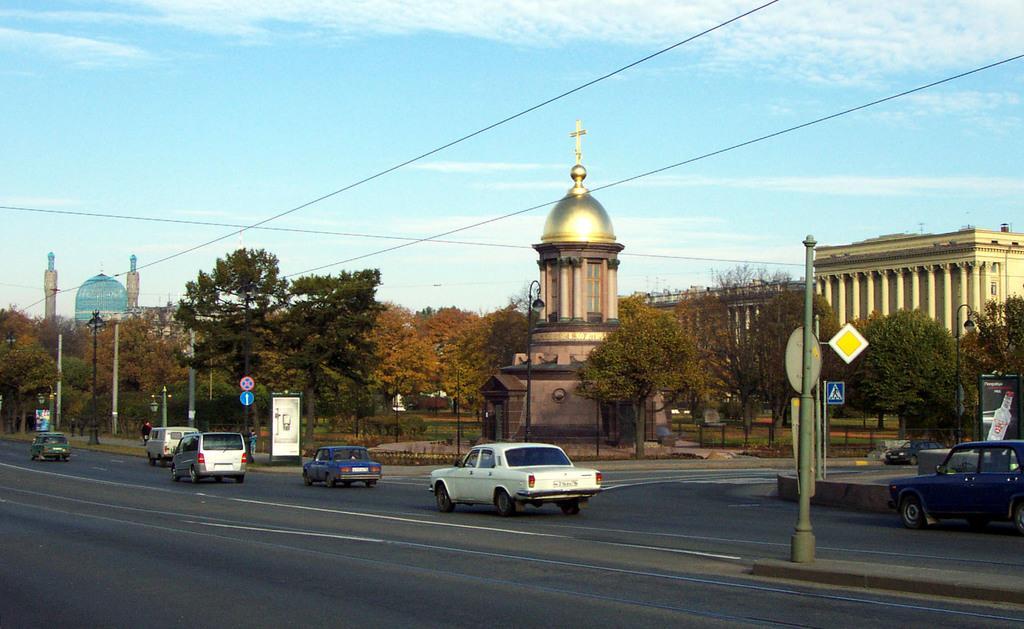Could you give a brief overview of what you see in this image? In this image there are buildings and trees. We can see vehicles on the road and there are poles. In the background there are wires and sky. 